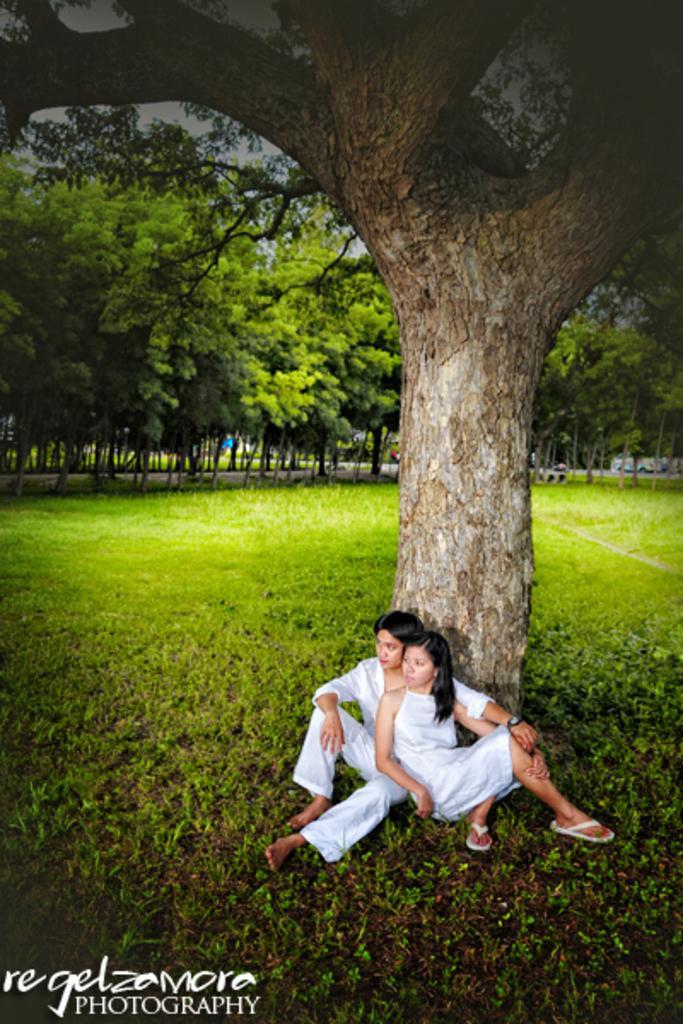In one or two sentences, can you explain what this image depicts? In this image we can see there are two people sitting beside the tree trunk. And there are trees and grass. And at the back it looks like a vehicle. 